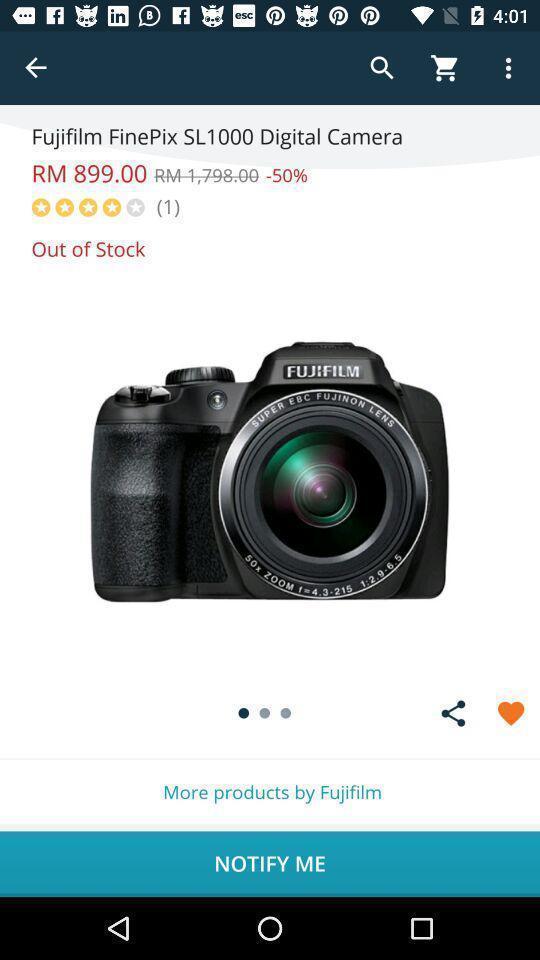Provide a textual representation of this image. Shopping app displayed an item with price. 